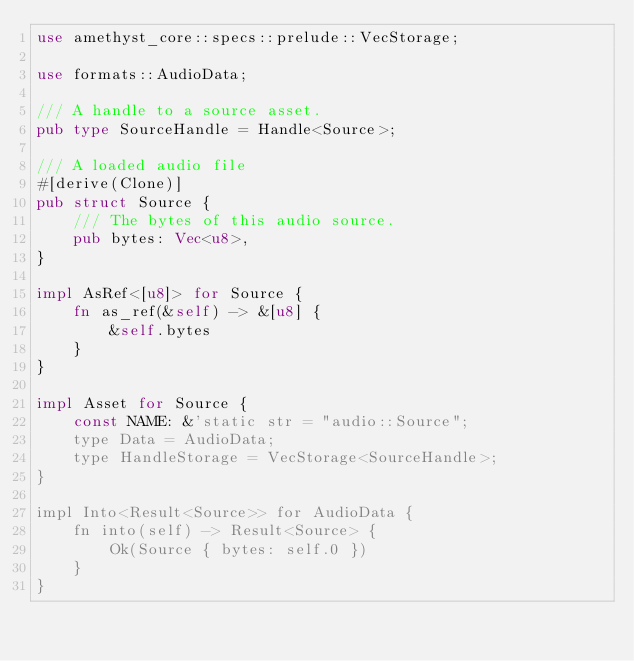<code> <loc_0><loc_0><loc_500><loc_500><_Rust_>use amethyst_core::specs::prelude::VecStorage;

use formats::AudioData;

/// A handle to a source asset.
pub type SourceHandle = Handle<Source>;

/// A loaded audio file
#[derive(Clone)]
pub struct Source {
    /// The bytes of this audio source.
    pub bytes: Vec<u8>,
}

impl AsRef<[u8]> for Source {
    fn as_ref(&self) -> &[u8] {
        &self.bytes
    }
}

impl Asset for Source {
    const NAME: &'static str = "audio::Source";
    type Data = AudioData;
    type HandleStorage = VecStorage<SourceHandle>;
}

impl Into<Result<Source>> for AudioData {
    fn into(self) -> Result<Source> {
        Ok(Source { bytes: self.0 })
    }
}
</code> 